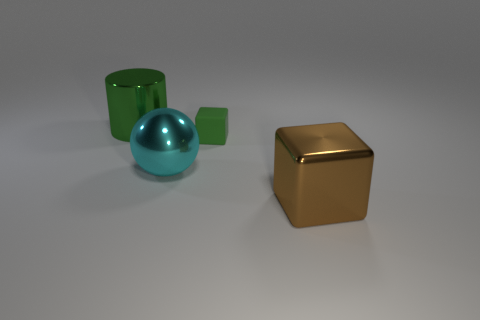There is a cube that is on the left side of the large shiny cube; are there any small matte blocks to the right of it?
Your answer should be compact. No. What is the shape of the green thing that is in front of the big green metallic thing that is behind the rubber cube?
Ensure brevity in your answer.  Cube. Is the number of blocks less than the number of small cyan metallic blocks?
Your answer should be compact. No. Is the material of the large cyan ball the same as the brown block?
Provide a short and direct response. Yes. There is a thing that is both to the right of the metal ball and behind the brown thing; what color is it?
Your answer should be compact. Green. Is there a cube that has the same size as the metal cylinder?
Give a very brief answer. Yes. There is a object in front of the cyan ball that is to the left of the tiny thing; what size is it?
Your answer should be very brief. Large. Are there fewer cyan spheres in front of the brown thing than brown blocks?
Your answer should be very brief. Yes. Does the metal cylinder have the same color as the small thing?
Offer a very short reply. Yes. How big is the cylinder?
Offer a very short reply. Large. 